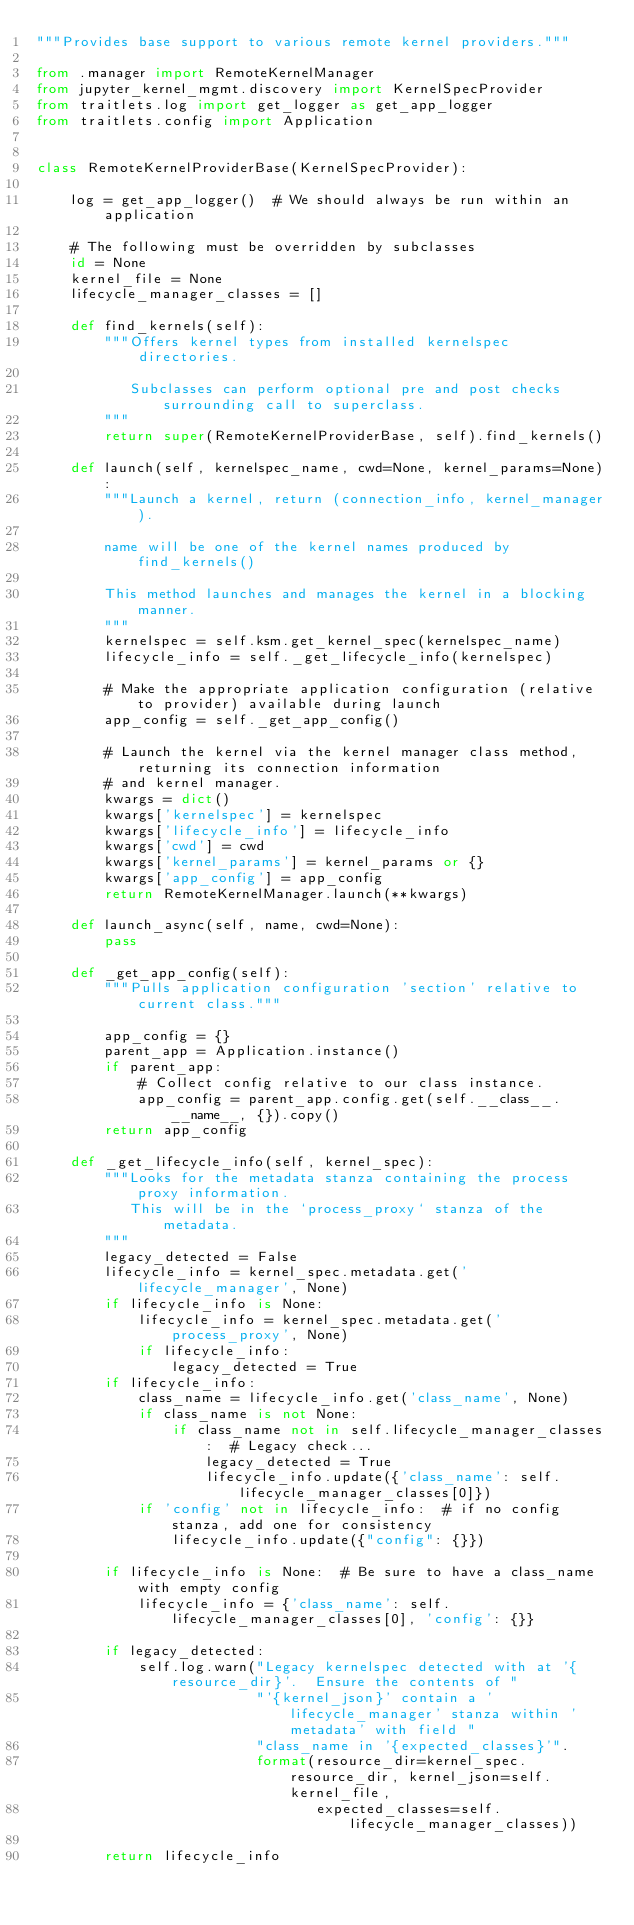Convert code to text. <code><loc_0><loc_0><loc_500><loc_500><_Python_>"""Provides base support to various remote kernel providers."""

from .manager import RemoteKernelManager
from jupyter_kernel_mgmt.discovery import KernelSpecProvider
from traitlets.log import get_logger as get_app_logger
from traitlets.config import Application


class RemoteKernelProviderBase(KernelSpecProvider):

    log = get_app_logger()  # We should always be run within an application

    # The following must be overridden by subclasses
    id = None
    kernel_file = None
    lifecycle_manager_classes = []

    def find_kernels(self):
        """Offers kernel types from installed kernelspec directories.

           Subclasses can perform optional pre and post checks surrounding call to superclass.
        """
        return super(RemoteKernelProviderBase, self).find_kernels()

    def launch(self, kernelspec_name, cwd=None, kernel_params=None):
        """Launch a kernel, return (connection_info, kernel_manager).

        name will be one of the kernel names produced by find_kernels()

        This method launches and manages the kernel in a blocking manner.
        """
        kernelspec = self.ksm.get_kernel_spec(kernelspec_name)
        lifecycle_info = self._get_lifecycle_info(kernelspec)

        # Make the appropriate application configuration (relative to provider) available during launch
        app_config = self._get_app_config()

        # Launch the kernel via the kernel manager class method, returning its connection information
        # and kernel manager.
        kwargs = dict()
        kwargs['kernelspec'] = kernelspec
        kwargs['lifecycle_info'] = lifecycle_info
        kwargs['cwd'] = cwd
        kwargs['kernel_params'] = kernel_params or {}
        kwargs['app_config'] = app_config
        return RemoteKernelManager.launch(**kwargs)

    def launch_async(self, name, cwd=None):
        pass

    def _get_app_config(self):
        """Pulls application configuration 'section' relative to current class."""

        app_config = {}
        parent_app = Application.instance()
        if parent_app:
            # Collect config relative to our class instance.
            app_config = parent_app.config.get(self.__class__.__name__, {}).copy()
        return app_config

    def _get_lifecycle_info(self, kernel_spec):
        """Looks for the metadata stanza containing the process proxy information.
           This will be in the `process_proxy` stanza of the metadata.
        """
        legacy_detected = False
        lifecycle_info = kernel_spec.metadata.get('lifecycle_manager', None)
        if lifecycle_info is None:
            lifecycle_info = kernel_spec.metadata.get('process_proxy', None)
            if lifecycle_info:
                legacy_detected = True
        if lifecycle_info:
            class_name = lifecycle_info.get('class_name', None)
            if class_name is not None:
                if class_name not in self.lifecycle_manager_classes:  # Legacy check...
                    legacy_detected = True
                    lifecycle_info.update({'class_name': self.lifecycle_manager_classes[0]})
            if 'config' not in lifecycle_info:  # if no config stanza, add one for consistency
                lifecycle_info.update({"config": {}})

        if lifecycle_info is None:  # Be sure to have a class_name with empty config
            lifecycle_info = {'class_name': self.lifecycle_manager_classes[0], 'config': {}}

        if legacy_detected:
            self.log.warn("Legacy kernelspec detected with at '{resource_dir}'.  Ensure the contents of "
                          "'{kernel_json}' contain a 'lifecycle_manager' stanza within 'metadata' with field "
                          "class_name in '{expected_classes}'".
                          format(resource_dir=kernel_spec.resource_dir, kernel_json=self.kernel_file,
                                 expected_classes=self.lifecycle_manager_classes))

        return lifecycle_info
</code> 